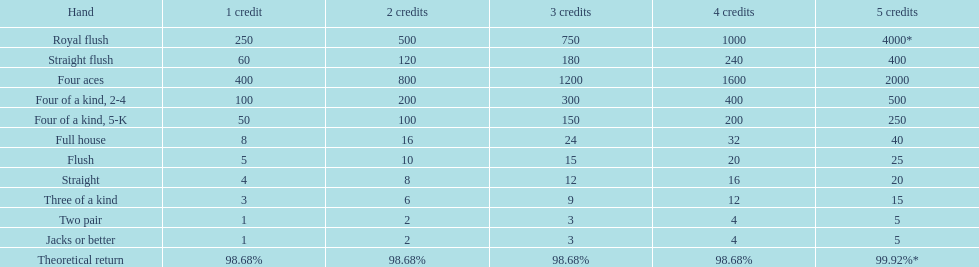What is the aggregate total of a straight flush with 3 credits? 180. 